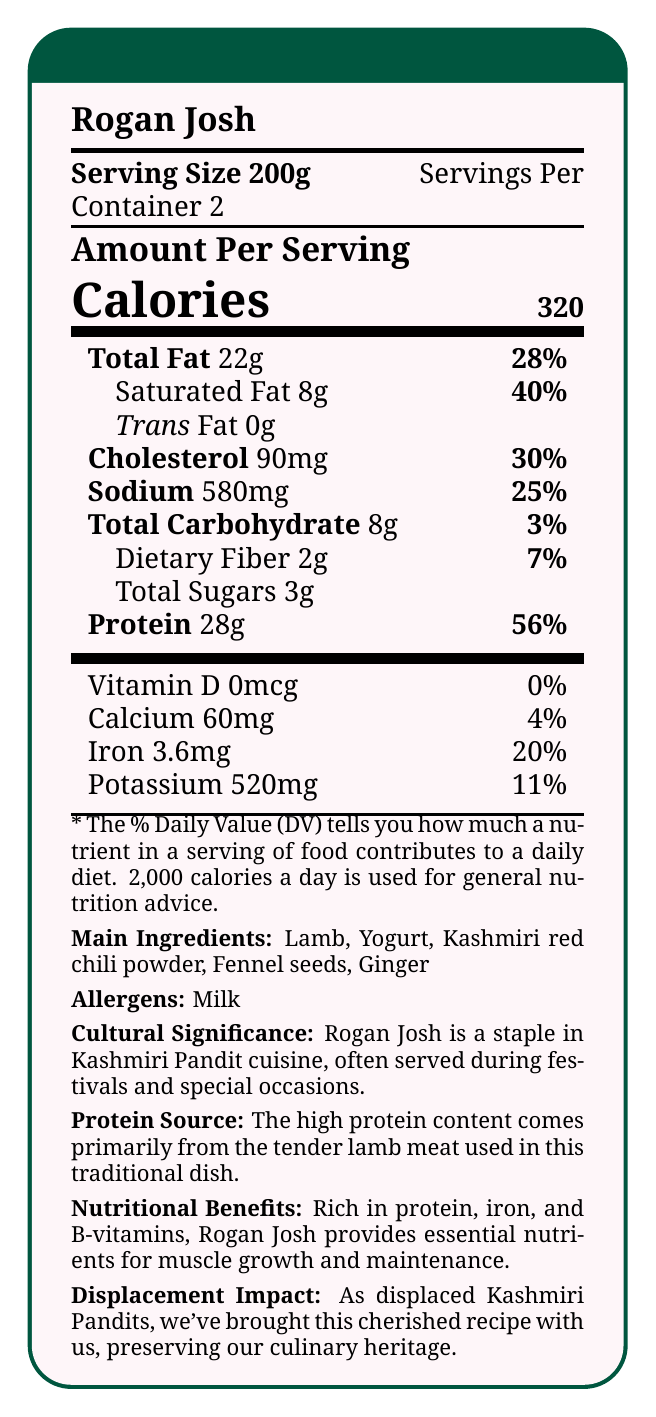What is the serving size of Rogan Josh? The serving size is listed as 200g under the serving details.
Answer: 200g How many servings are there per container of Rogan Josh? The document specifies that there are 2 servings per container.
Answer: 2 What is the main protein source in Rogan Josh? The additional info section states that the high protein content comes primarily from the tender lamb meat used in the dish.
Answer: Lamb How much protein does one serving of Rogan Josh contain? The amount of protein is listed as 28g per serving.
Answer: 28g What percentage of Daily Value does the protein content contribute? The document shows that the protein content contributes 56% to the Daily Value.
Answer: 56% What are the main ingredients of Rogan Josh? The main ingredients are listed in the additional info section.
Answer: Lamb, Yogurt, Kashmiri red chili powder, Fennel seeds, Ginger Which of the following statements about Rogan Josh's nutritional benefits is true? A. It is low in protein. B. It is rich in iron. C. It has no cholesterol. The document states that Rogan Josh is rich in iron.
Answer: B What is the amount of cholesterol in a serving of Rogan Josh? A. 30mg B. 60mg C. 90mg The document lists the cholesterol amount as 90mg per serving.
Answer: C Does Rogan Josh contain any trans fat? The trans fat amount is listed as 0g.
Answer: No Is the % Daily Value for dietary fiber less than 10%? The document states that the % Daily Value for dietary fiber is 7%.
Answer: Yes Summarize the key nutritional information and cultural significance of Rogan Josh. The document provides nutritional facts like calories, protein, and fat content. It also highlights the cultural significance of the dish, which is a traditional food for Kashmiri Pandits.
Answer: Rogan Josh is a traditional Kashmiri Pandit dish with 320 calories per 200g serving, containing 28g of protein and a high amount of iron. It is rich in protein primarily from lamb meat. It also includes ingredients like yogurt and Kashmiri red chili powder and is considered a staple food during festivals. What is the main allergen present in Rogan Josh? The allergen information lists milk.
Answer: Milk How much calcium does a serving of Rogan Josh provide? The document specifies that a serving contains 60mg of calcium.
Answer: 60mg Are there any details on how this dish contributes to muscle growth? The document mentions that Rogan Josh provides essential nutrients for muscle growth and maintenance.
Answer: Yes What are some of the challenges faced by displaced Kashmiri Pandits in preserving this dish? The document states that displaced Kashmiri Pandits have preserved the recipe but doesn't provide specific challenges they faced.
Answer: Not enough information Is Rogan Josh low in carbohydrates? The total carbohydrate content per serving is 8g, which is relatively low.
Answer: Yes 